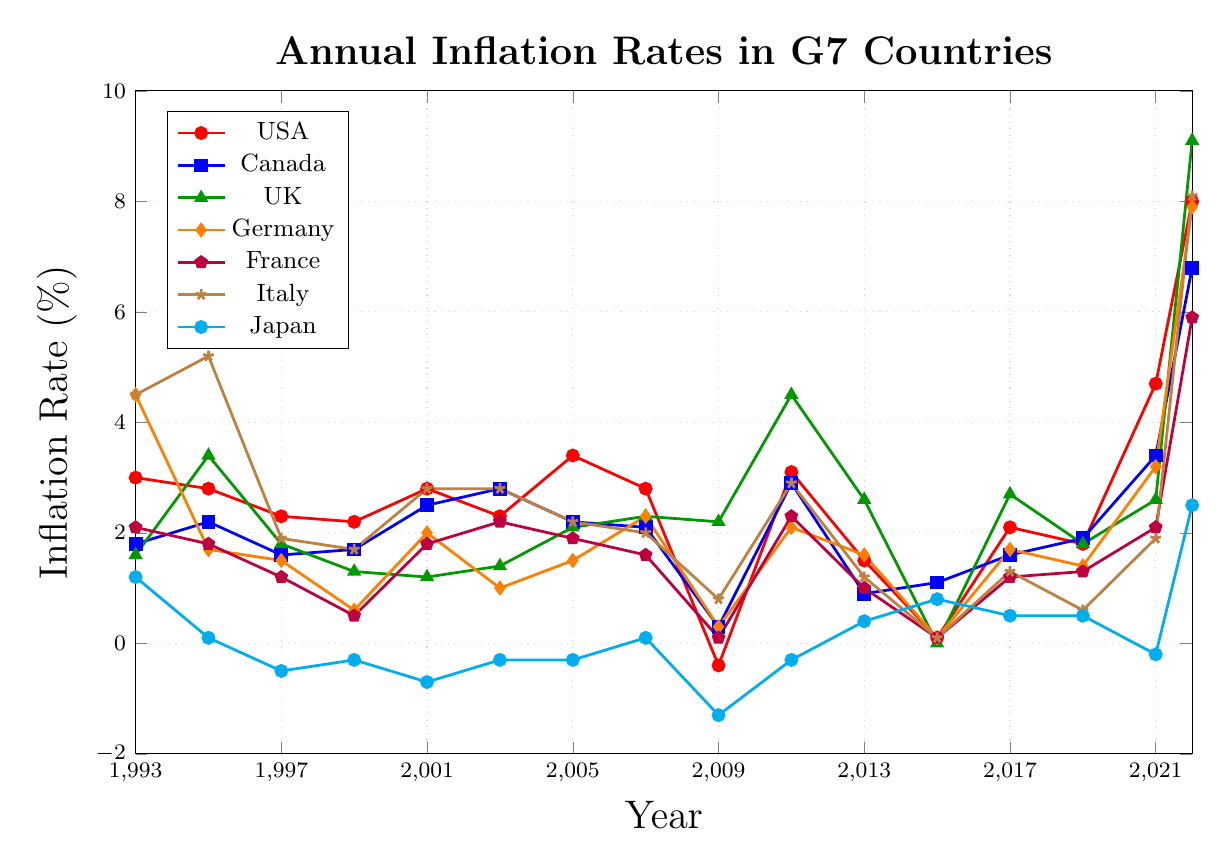Which G7 country had the highest inflation rate in 2022? Look at the inflation rates for each country in 2022. The UK had the highest rate at 9.1%
Answer: UK What was the difference in inflation rate between Germany and Italy in 1995? Subtract the inflation rate of Germany from that of Italy in 1995. Italy had 5.2% and Germany had 1.7%, so 5.2% - 1.7% = 3.5%
Answer: 3.5% Compare the inflation trends of Canada and Japan from 1993 to 2022. Which country experienced more frequent changes in their inflation rate? Observe the line plots for Canada (blue) and Japan (cyan) across the years. Japan had negative inflation rates multiple times and a wider fluctuation, while Canada was relatively more stable.
Answer: Japan How did the inflation rate for the USA change from 2009 to 2013? Look at the values for the USA in 2009 (-0.4%) and 2013 (1.5%). The rate increased by 0.4% + 1.5% from 2009 to 2013.
Answer: Increased by 1.9% Identify if any country had a constant inflation rate of 0.1% over any consecutive years. Analyze the line plots for all countries. France had inflation rates of 0.1% in both 2015 and 2017.
Answer: France Which two years did the UK have the highest inflation rate, and what were the rates? Check the inflation rates for the UK. The years with the highest rates are 2011 (4.5%) and 2022 (9.1%).
Answer: 2011 and 2022 What is the visual color representing Italy, and how did its inflation rate change from 1993 to 2001? Italy is represented by a brown line. The rate decreased from 4.5% in 1993 to 2.8% in 2001.
Answer: Brown, decreased from 4.5% to 2.8% Calculate the average inflation rate for Germany from 2015 to 2021. Add the rates for Germany from 2015 (0.1%), 2017 (1.7%), 2019 (1.4%), and 2021 (3.2%) and divide by 4. (0.1 + 1.7 + 1.4 + 3.2) / 4 = 1.6%.
Answer: 1.6% Compare the inflation rate trends of the UK and France in 2022. Which country had a higher rate and by how much? Check the rates for UK (9.1%) and France (5.9%) in 2022. Subtract the rate of France from that of the UK. 9.1% - 5.9% = 3.2%.
Answer: UK, by 3.2% How often did Japan experience negative inflation rates in the given period? Count the number of negative inflation rates for Japan in the data. Japan had negative rates in 1997, 1999, 2001, 2003, 2005, 2009, 2011, and 2021 (8 times).
Answer: 8 times 